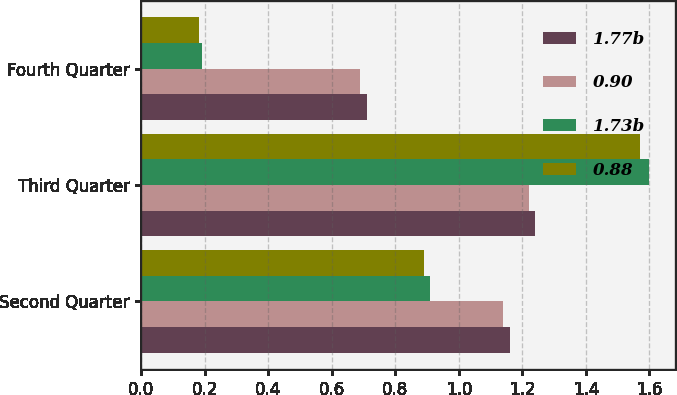Convert chart. <chart><loc_0><loc_0><loc_500><loc_500><stacked_bar_chart><ecel><fcel>Second Quarter<fcel>Third Quarter<fcel>Fourth Quarter<nl><fcel>1.77b<fcel>1.16<fcel>1.24<fcel>0.71<nl><fcel>0.90<fcel>1.14<fcel>1.22<fcel>0.69<nl><fcel>1.73b<fcel>0.91<fcel>1.6<fcel>0.19<nl><fcel>0.88<fcel>0.89<fcel>1.57<fcel>0.18<nl></chart> 